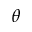Convert formula to latex. <formula><loc_0><loc_0><loc_500><loc_500>\theta</formula> 